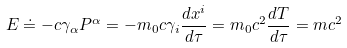Convert formula to latex. <formula><loc_0><loc_0><loc_500><loc_500>E \doteq - c \gamma _ { \alpha } P ^ { \alpha } = - m _ { 0 } c \gamma _ { i } \frac { d x ^ { i } } { d \tau } = m _ { 0 } c ^ { 2 } \frac { d T } { d \tau } = m c ^ { 2 }</formula> 